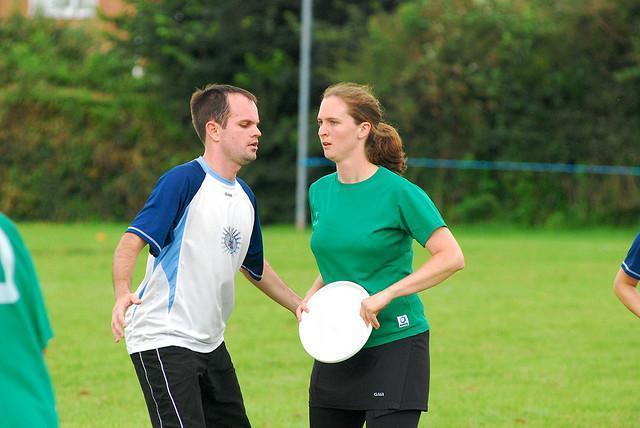How many stripes are on the guys shorts?
Give a very brief answer. 2. How many people are visible?
Give a very brief answer. 3. How many frisbees are in the photo?
Give a very brief answer. 1. How many of the tracks have a train on them?
Give a very brief answer. 0. 